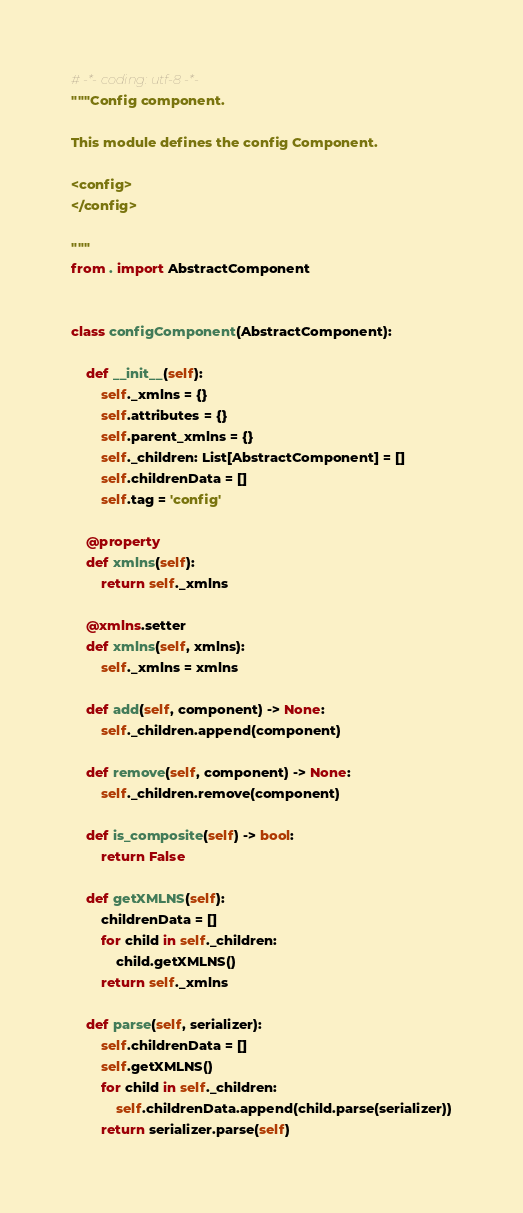<code> <loc_0><loc_0><loc_500><loc_500><_Python_># -*- coding: utf-8 -*-
"""Config component.

This module defines the config Component.

<config>
</config>

"""
from . import AbstractComponent


class configComponent(AbstractComponent):

    def __init__(self):
        self._xmlns = {}
        self.attributes = {}
        self.parent_xmlns = {}
        self._children: List[AbstractComponent] = []
        self.childrenData = []
        self.tag = 'config'

    @property
    def xmlns(self):
        return self._xmlns

    @xmlns.setter
    def xmlns(self, xmlns):
        self._xmlns = xmlns

    def add(self, component) -> None:
        self._children.append(component)

    def remove(self, component) -> None:
        self._children.remove(component)

    def is_composite(self) -> bool:
        return False

    def getXMLNS(self):
        childrenData = []
        for child in self._children:
            child.getXMLNS()
        return self._xmlns

    def parse(self, serializer):
        self.childrenData = []
        self.getXMLNS()
        for child in self._children:
            self.childrenData.append(child.parse(serializer))
        return serializer.parse(self)
</code> 